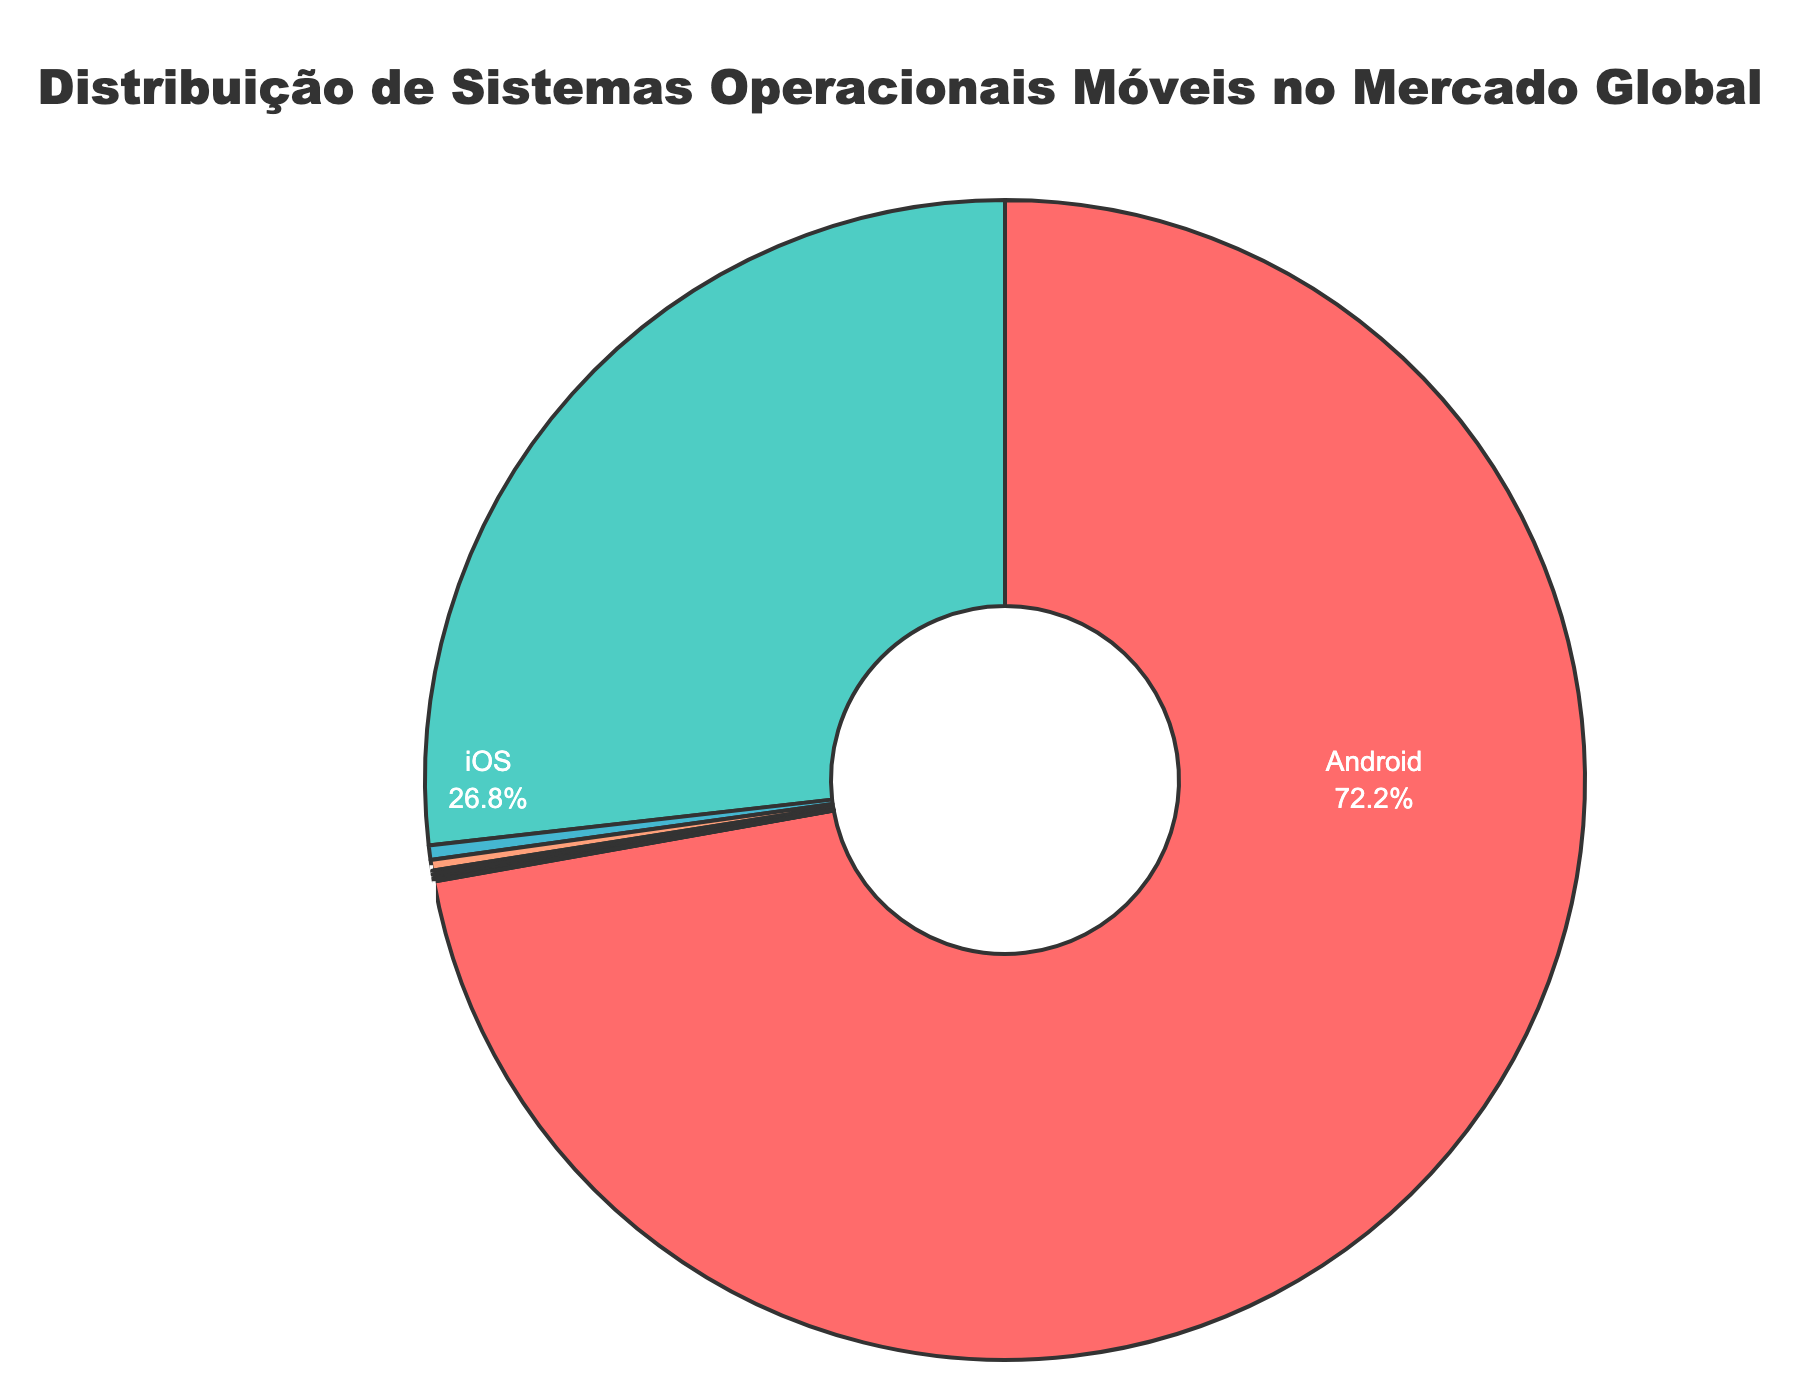What's the market share of Android compared to iOS? Android holds 72.2% of the market, while iOS holds 26.8%. To compare, iOS has 45.4% less market share than Android.
Answer: 45.4% What is the combined market share of HarmonyOS and KaiOS? HarmonyOS has 0.4% and KaiOS has 0.3%. Adding these together gives 0.4% + 0.3% = 0.7%.
Answer: 0.7% What percentage of the market do all systems other than Android and iOS hold? Subtract the combined percentage of Android and iOS (72.2% + 26.8% = 99%) from 100%. The remaining market share is 100% - 99% = 1%.
Answer: 1% Is the market share of Linux greater than or equal to Samsung Tizen? Both Linux and Samsung Tizen hold 0.1% of the market share. Hence, they are equal.
Answer: Equal Which operating system holds the smallest market share? Both Sailfish OS and Ubuntu Touch have the smallest market shares with 0.01% each.
Answer: Sailfish OS and Ubuntu Touch How much larger is the market share of iOS compared to the market share of Windows Phone? iOS holds 26.8%, and Windows Phone holds 0.05%. The difference is 26.8% - 0.05% = 26.75%.
Answer: 26.75% What is the average market share of the bottom five operating systems? The bottom five operating systems are Windows Phone (0.05%), BlackBerry OS (0.03%), Sailfish OS (0.01%), Ubuntu Touch (0.01%), and Linux (0.1%). Their average market share is (0.05% + 0.03% + 0.01% + 0.01% + 0.1%) / 5 = 0.04%.
Answer: 0.04% Which operating systems have a market share greater than 0.5% but less than 1%? None of the operating systems fall in this range.
Answer: None What is the sum of the market shares of all operating systems with less than 0.1% market share? These are Windows Phone (0.05%), BlackBerry OS (0.03%), Sailfish OS (0.01%), and Ubuntu Touch (0.01%). Adding these gives 0.05% + 0.03% + 0.01% + 0.01% = 0.1%.
Answer: 0.1% What color is the segment representing the Android market share? The segment representing Android is colored red.
Answer: Red 